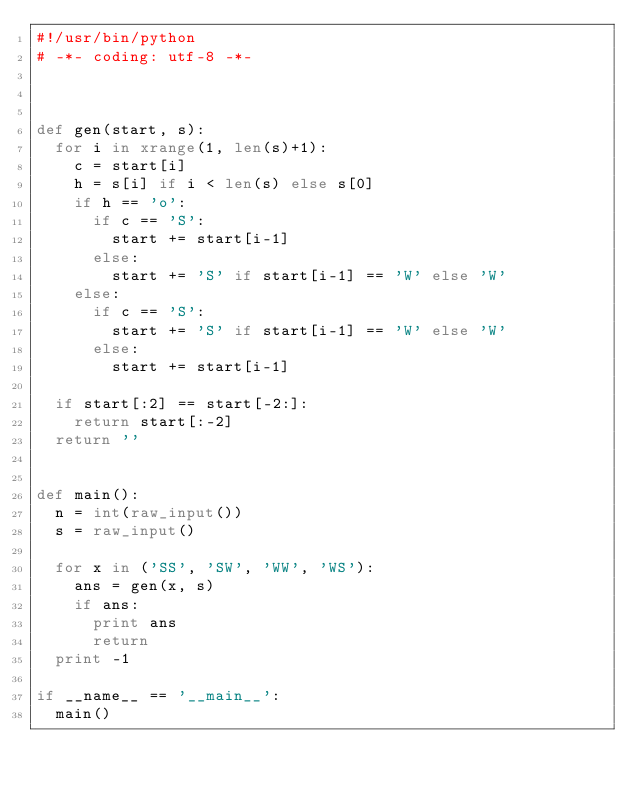Convert code to text. <code><loc_0><loc_0><loc_500><loc_500><_Python_>#!/usr/bin/python
# -*- coding: utf-8 -*-



def gen(start, s):
	for i in xrange(1, len(s)+1):
		c = start[i]
		h = s[i] if i < len(s) else s[0]
		if h == 'o':
			if c == 'S':
				start += start[i-1]
			else:
				start += 'S' if start[i-1] == 'W' else 'W'
		else:
			if c == 'S':
				start += 'S' if start[i-1] == 'W' else 'W'
			else:
				start += start[i-1]

	if start[:2] == start[-2:]:
		return start[:-2]
	return ''


def main():
	n = int(raw_input())
	s = raw_input()

	for x in ('SS', 'SW', 'WW', 'WS'):
		ans = gen(x, s)
		if ans:
			print ans
			return
	print -1

if __name__ == '__main__':
	main()</code> 